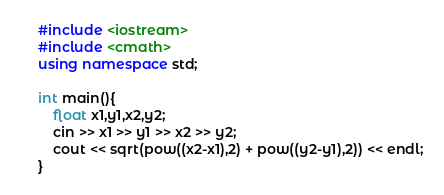<code> <loc_0><loc_0><loc_500><loc_500><_C++_>#include <iostream>
#include <cmath>
using namespace std;
 
int main(){
    float x1,y1,x2,y2;
    cin >> x1 >> y1 >> x2 >> y2;
    cout << sqrt(pow((x2-x1),2) + pow((y2-y1),2)) << endl;
}
</code> 